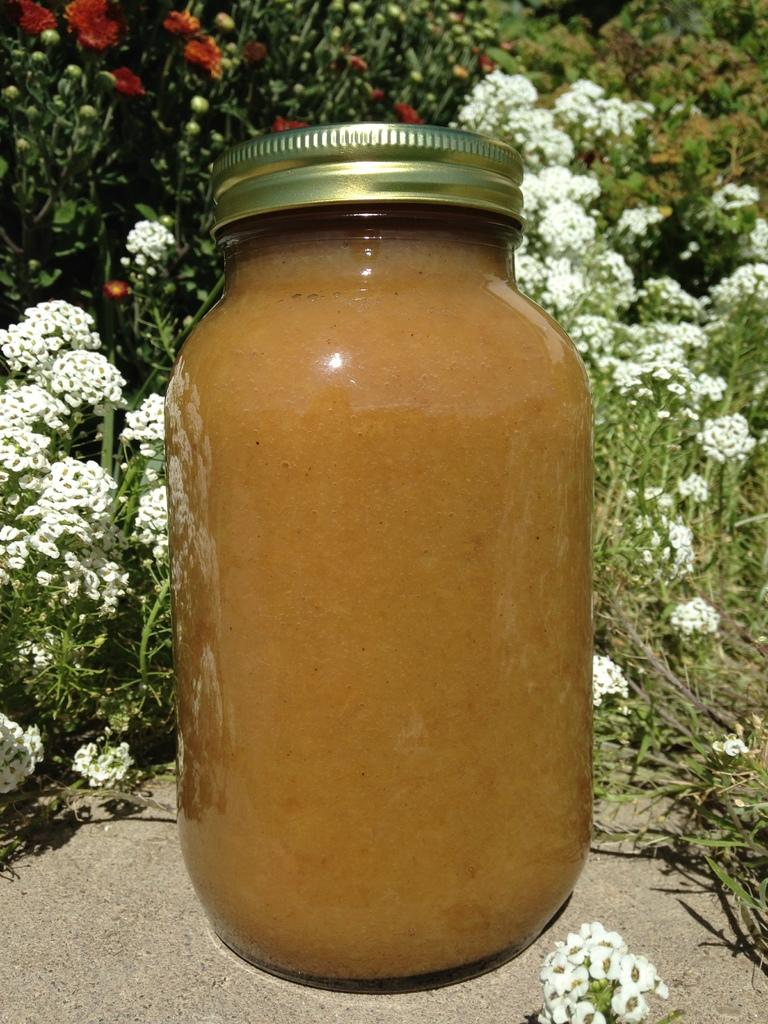What is the main object in the image? There is a glass bottle in the image. What can be found inside the glass bottle? There is an unspecified object inside the glass bottle. What type of vegetation is visible in the background of the image? There are plants and flowers in the background of the image. What is the name of the daughter who is holding the cap in the image? There is no daughter or cap present in the image. 